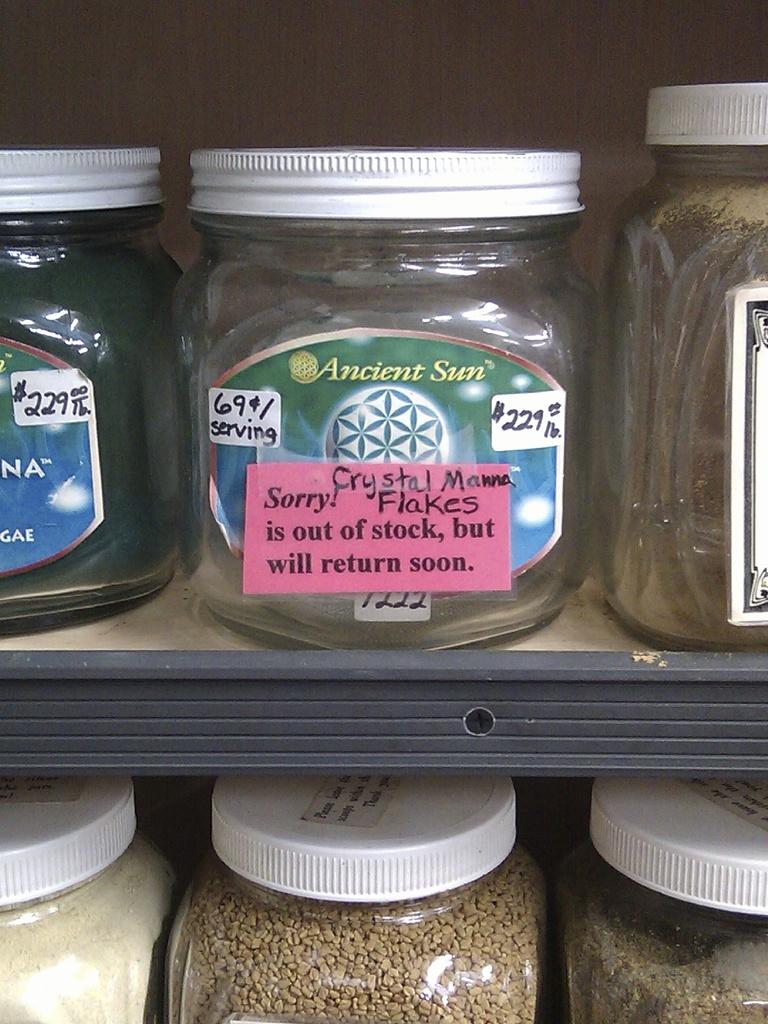What is in the jar?
Provide a short and direct response. Crystal manna flakes. 